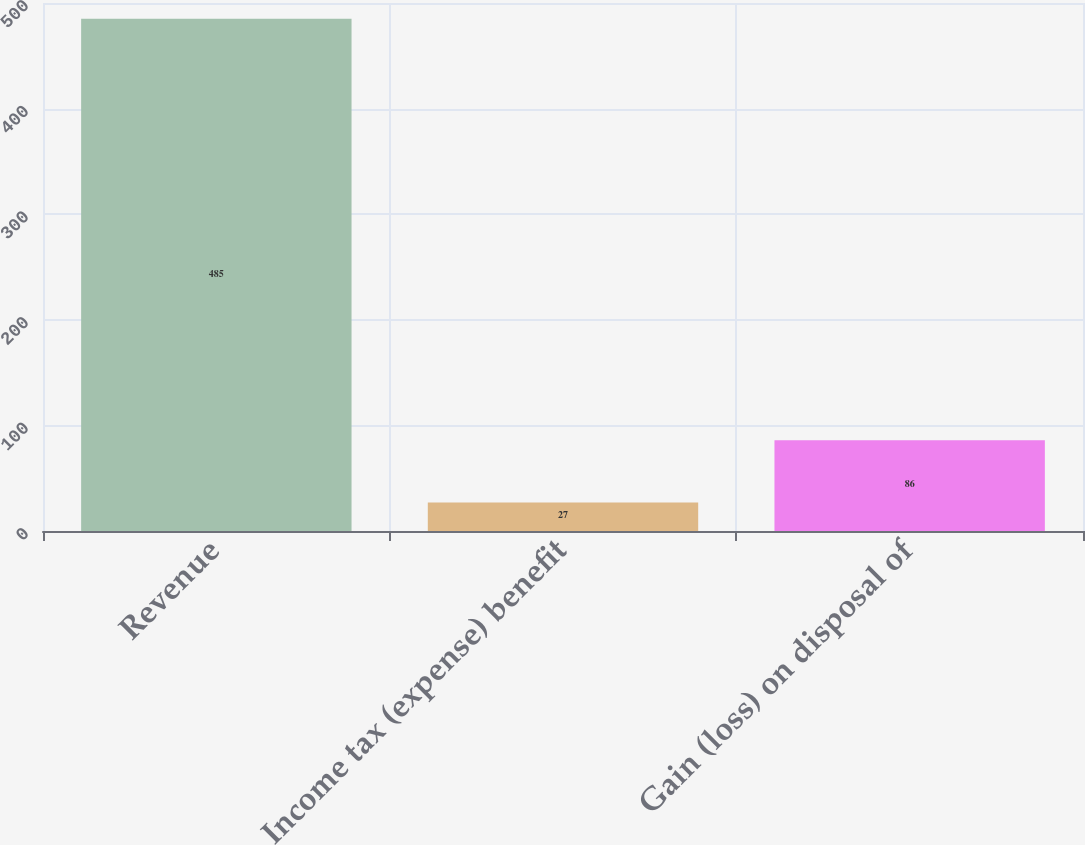Convert chart to OTSL. <chart><loc_0><loc_0><loc_500><loc_500><bar_chart><fcel>Revenue<fcel>Income tax (expense) benefit<fcel>Gain (loss) on disposal of<nl><fcel>485<fcel>27<fcel>86<nl></chart> 